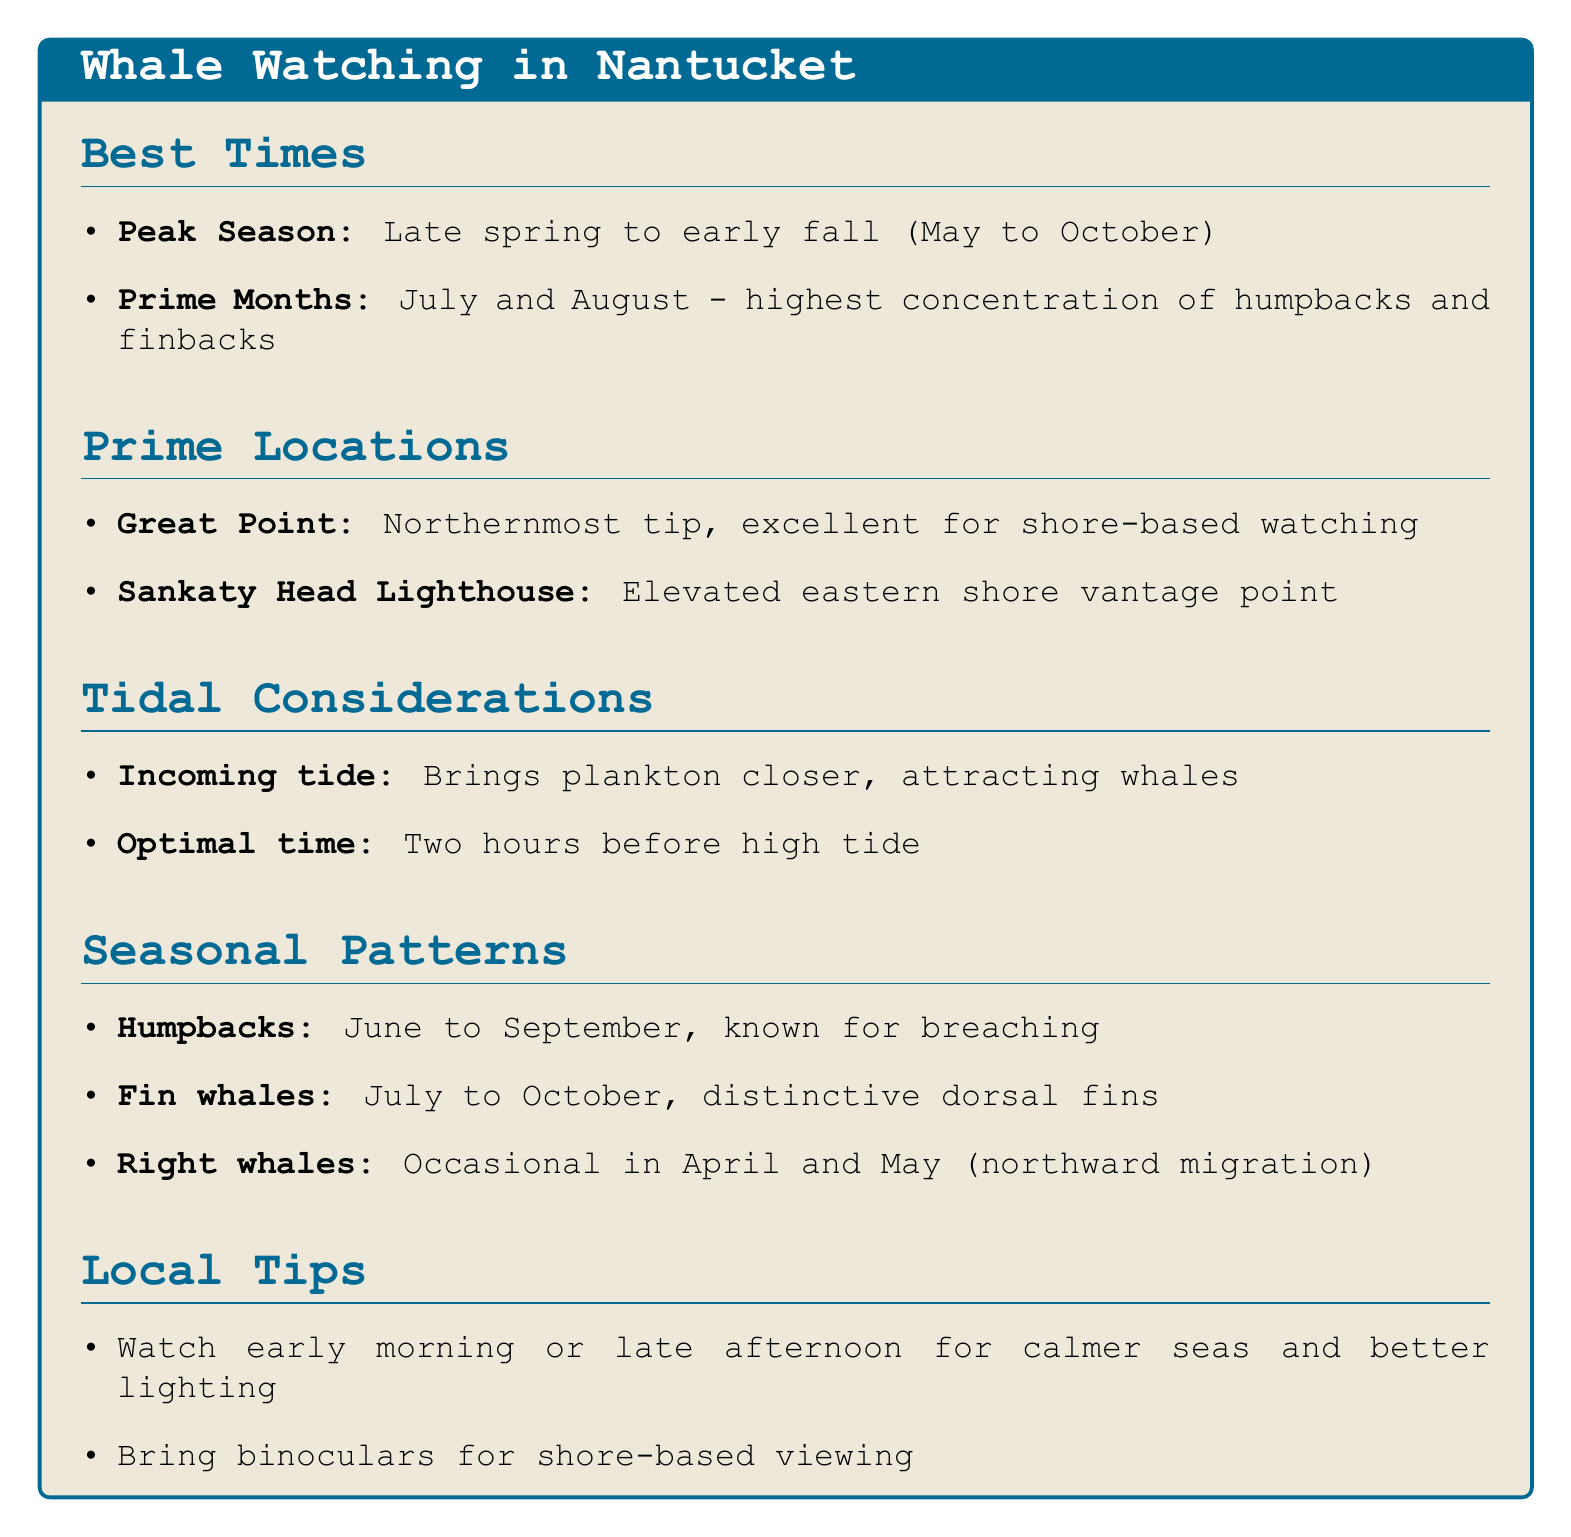what is the peak season for whale watching? The peak season for whale watching is defined as late spring to early fall, which encompasses the months from May to October.
Answer: late spring to early fall (May to October) what are the prime months for whale concentration? The prime months identified for the highest concentration of whales, specifically humpbacks and finbacks, are July and August.
Answer: July and August where is the northernmost tip of Nantucket? The northernmost tip of Nantucket, which is excellent for shore-based whale watching, is referred to as Great Point.
Answer: Great Point what time is considered optimal for whale activity? The document specifies that two hours before high tide is the optimal time for whale activity near the coast.
Answer: two hours before high tide during which months are humpback whales most common? Humpback whales are most commonly seen from June to September, as noted in the document.
Answer: June to September what is suggested for better whale spotting from shore locations? The document advises bringing binoculars as they are essential for spotting whales from shore-based locations.
Answer: binoculars when is the best time of day for calmer seas? The best times for calmer seas and better lighting for spotting whale spouts are early morning or late afternoon.
Answer: early morning or late afternoon what species of whales can be seen from July to October? The document specifies that fin whales are frequently spotted from July to October.
Answer: Fin whales what defines the right whales' migration observation period? Occasional sightings of right whales can be noted during April and May, as they migrate northward.
Answer: April and May 